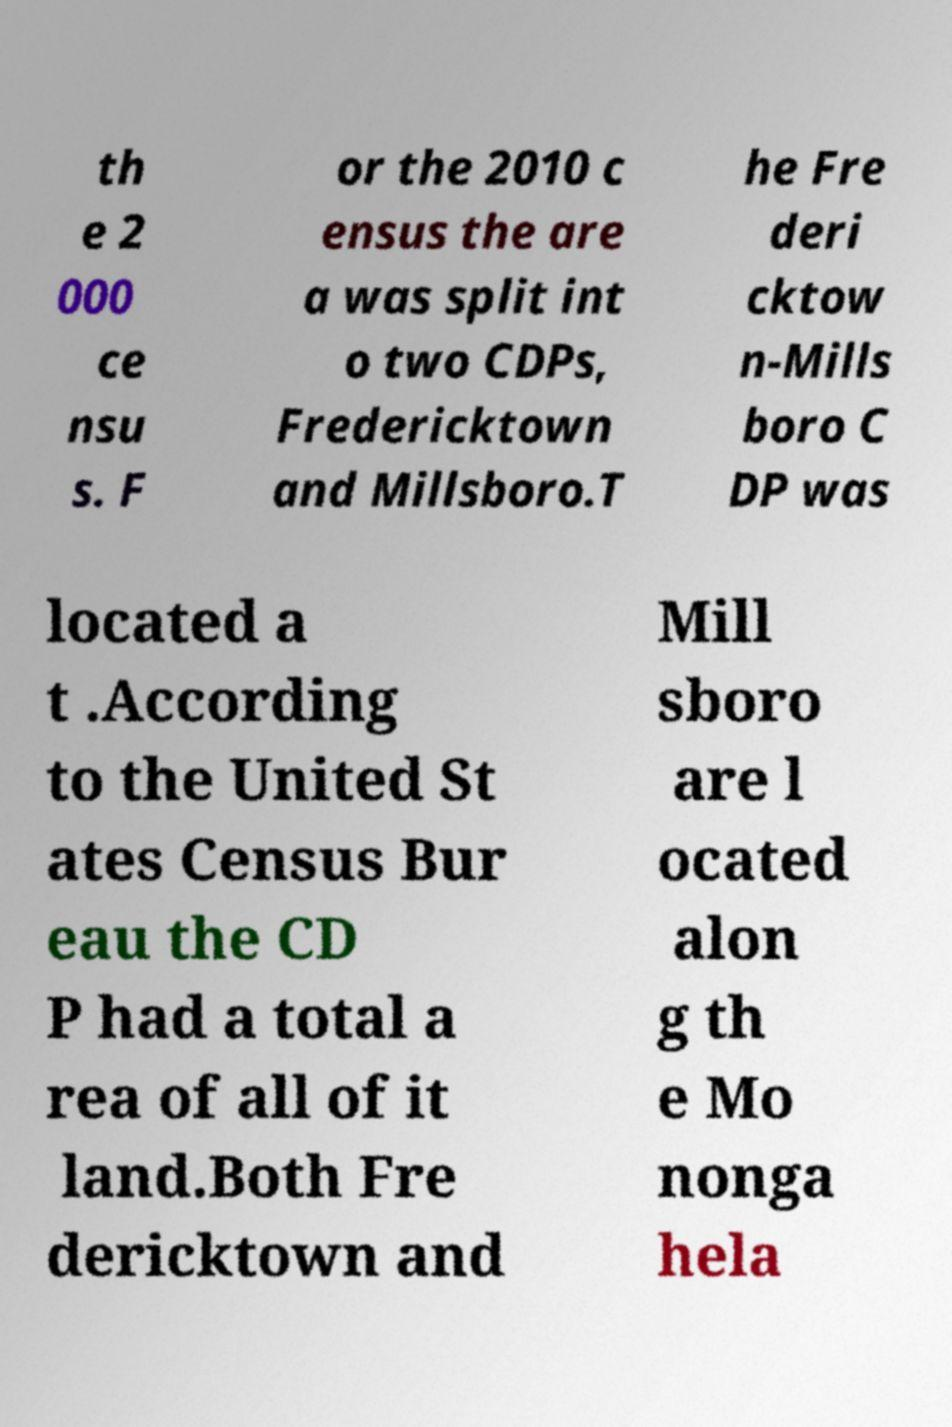What messages or text are displayed in this image? I need them in a readable, typed format. th e 2 000 ce nsu s. F or the 2010 c ensus the are a was split int o two CDPs, Fredericktown and Millsboro.T he Fre deri cktow n-Mills boro C DP was located a t .According to the United St ates Census Bur eau the CD P had a total a rea of all of it land.Both Fre dericktown and Mill sboro are l ocated alon g th e Mo nonga hela 